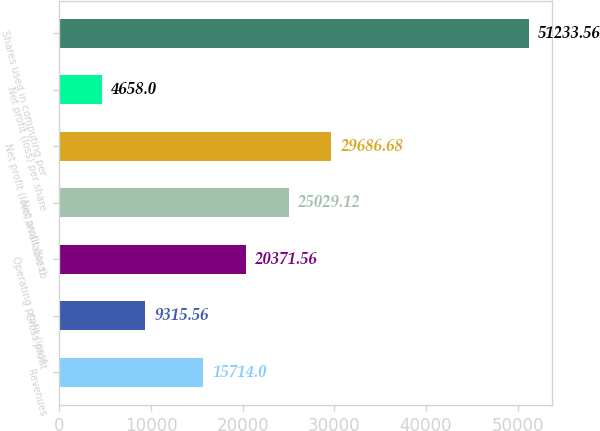<chart> <loc_0><loc_0><loc_500><loc_500><bar_chart><fcel>Revenues<fcel>Gross profit<fcel>Operating profit (loss)<fcel>Net profit (loss)<fcel>Net profit (loss) available to<fcel>Net profit (loss) per share<fcel>Shares used in computing per<nl><fcel>15714<fcel>9315.56<fcel>20371.6<fcel>25029.1<fcel>29686.7<fcel>4658<fcel>51233.6<nl></chart> 